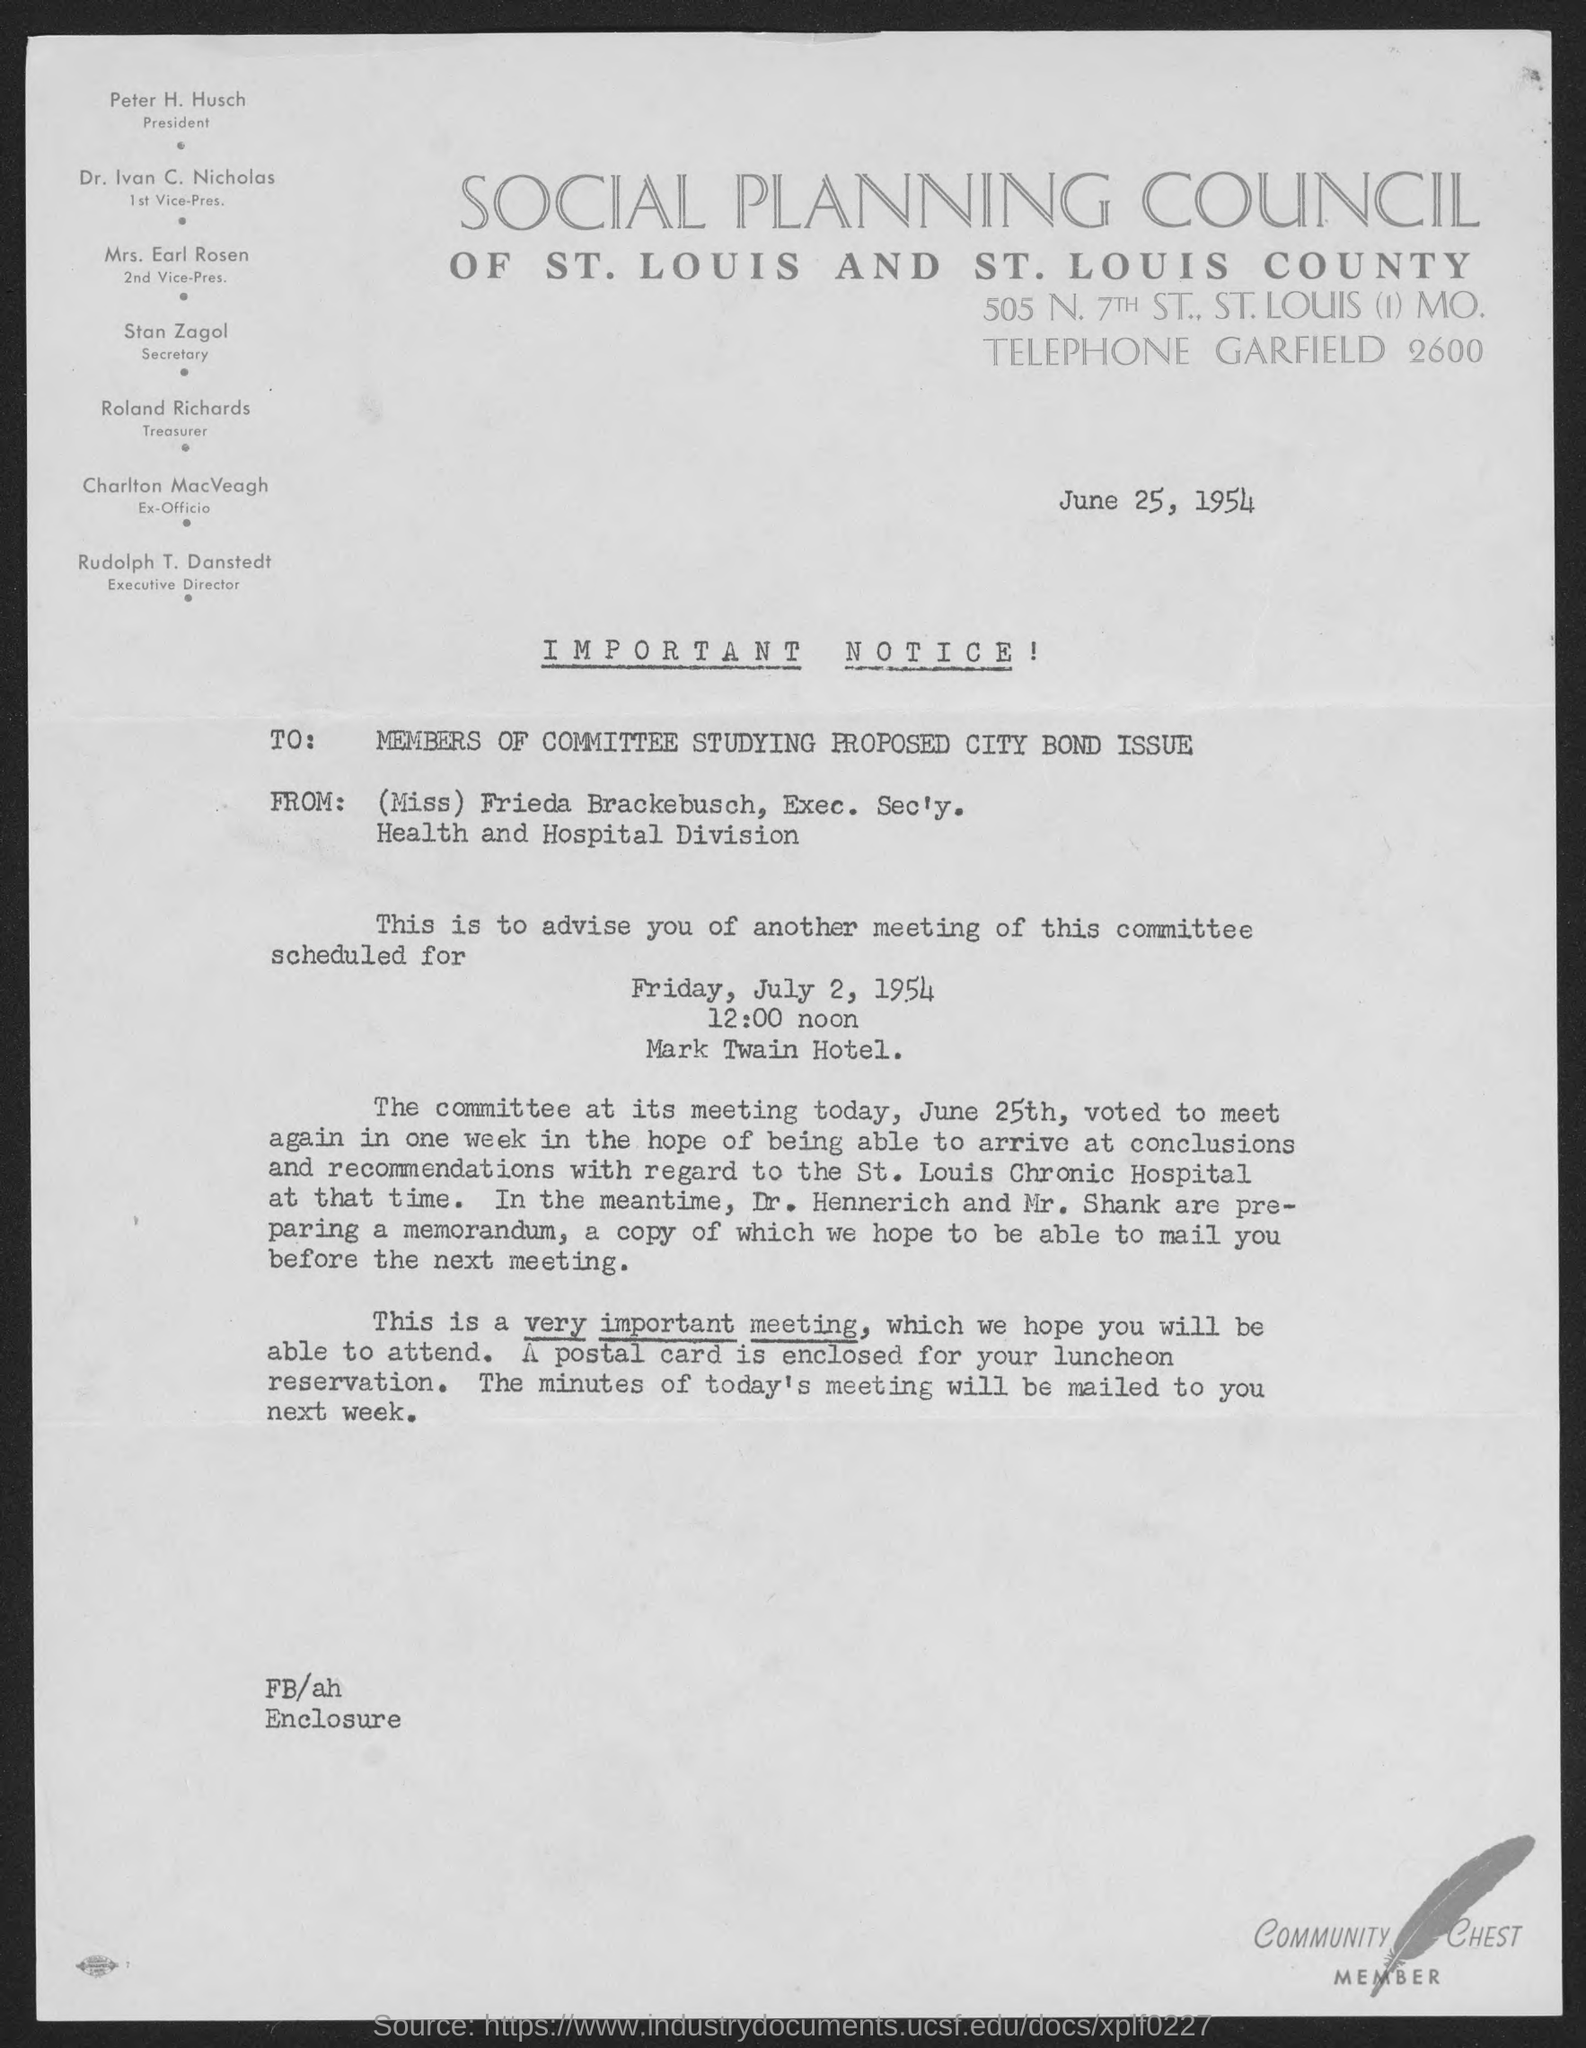Draw attention to some important aspects in this diagram. The Executive Secretary of the Health and Hospital Division is a woman named Miss Frieda Brackebusch. The President of the Social Planning Council of St. Louis and St. Louis County is Peter H. Husch. The Social Planning Council of St. Louis and St. Louis County has elected Dr. Ivan C. Nicholas as its first vice-president. Dr. Nicholas is a highly respected and accomplished individual with a proven track record of leadership and community service. The ex-officio of the Social Planning Council of St. Louis and St. Louis County is Charlton Macveagh. The 2nd vice-president of the Social Planning Council of St. Louis and St. Louis County is Mrs. Earl Rosen. 